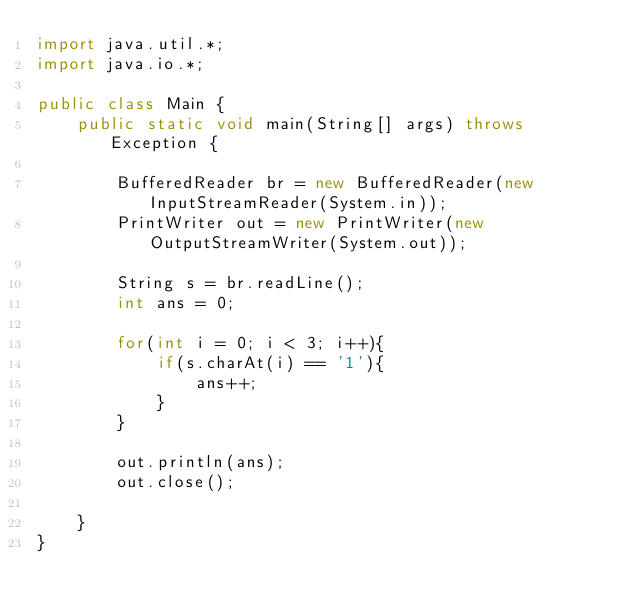Convert code to text. <code><loc_0><loc_0><loc_500><loc_500><_Java_>import java.util.*;
import java.io.*;

public class Main {
    public static void main(String[] args) throws Exception {

        BufferedReader br = new BufferedReader(new InputStreamReader(System.in));
        PrintWriter out = new PrintWriter(new OutputStreamWriter(System.out));
        
        String s = br.readLine();
        int ans = 0;
        
        for(int i = 0; i < 3; i++){
            if(s.charAt(i) == '1'){
                ans++;
            }
        }
        
        out.println(ans);
        out.close();
        
    }
}</code> 